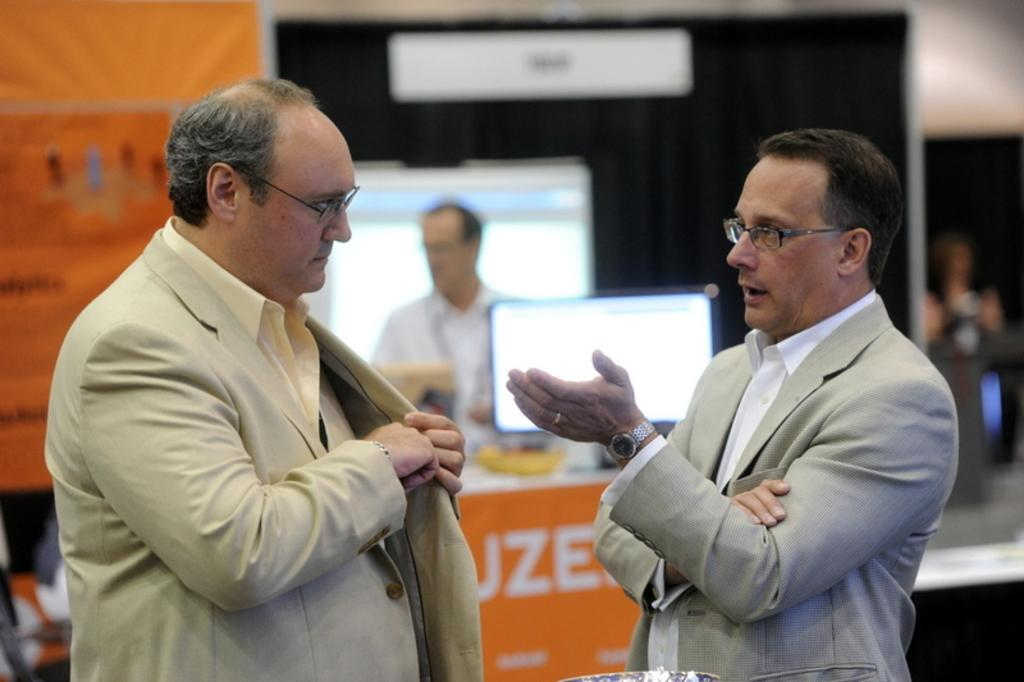How many people are in the foreground of the image? There are two men in the foreground of the image. What is the second person doing in the image? The second person is talking. Can you describe the background of the men in the image? The background of the men is blurred. What type of calculator can be seen on the plane in the image? There is no calculator or plane present in the image. 